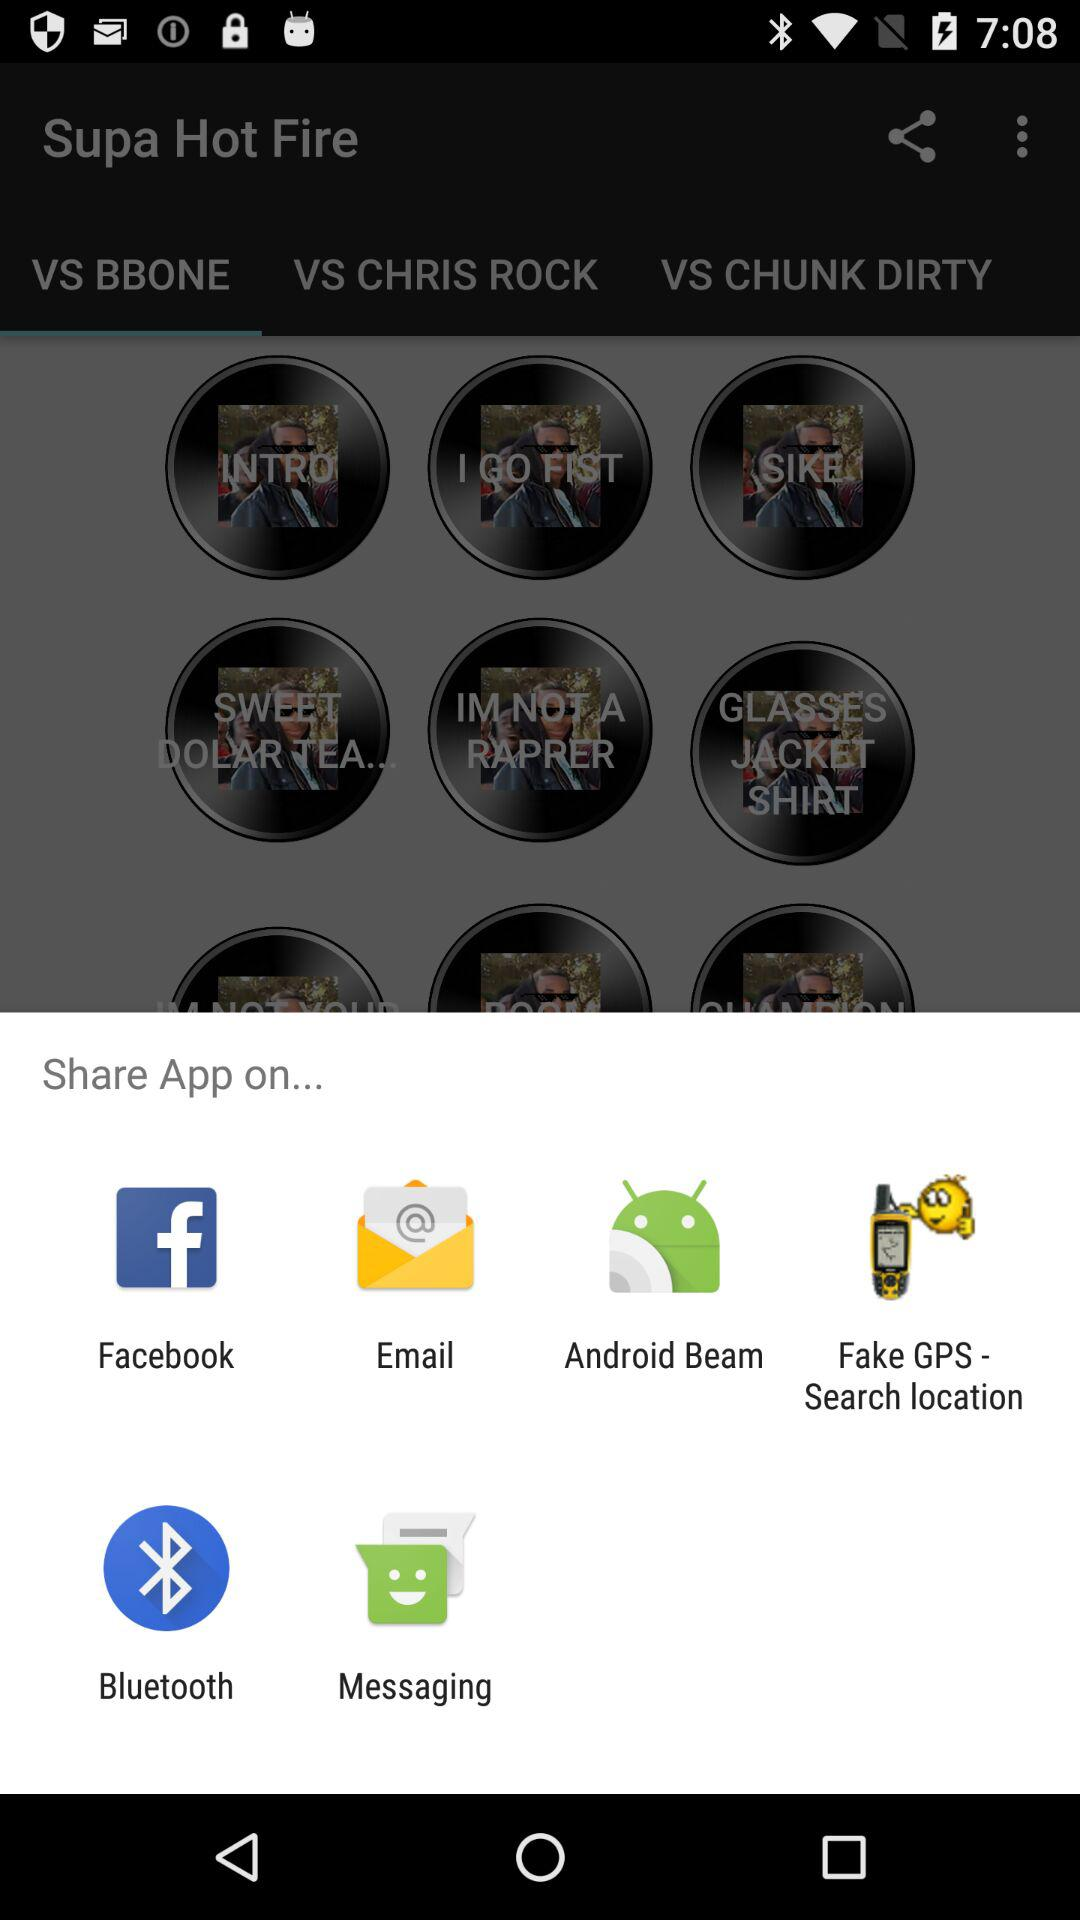What app can we use to share? You can share it with Facebook, Email, Android Beam, Fake GPS - Search location, Bluetooth and Messaging. 